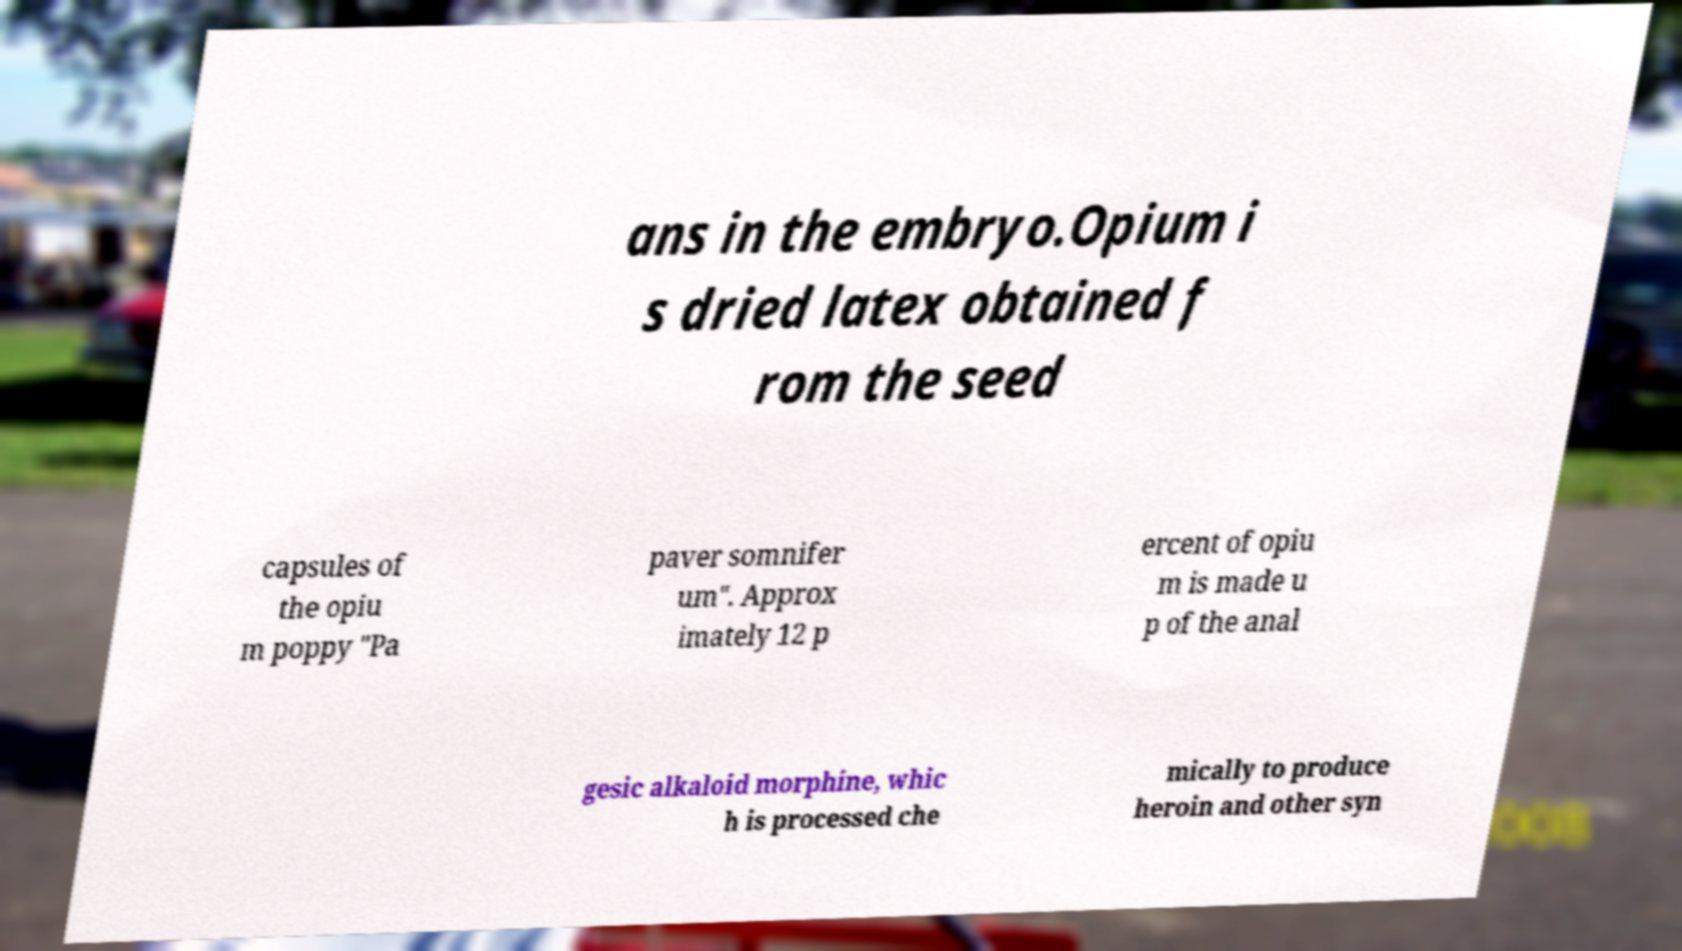I need the written content from this picture converted into text. Can you do that? ans in the embryo.Opium i s dried latex obtained f rom the seed capsules of the opiu m poppy "Pa paver somnifer um". Approx imately 12 p ercent of opiu m is made u p of the anal gesic alkaloid morphine, whic h is processed che mically to produce heroin and other syn 